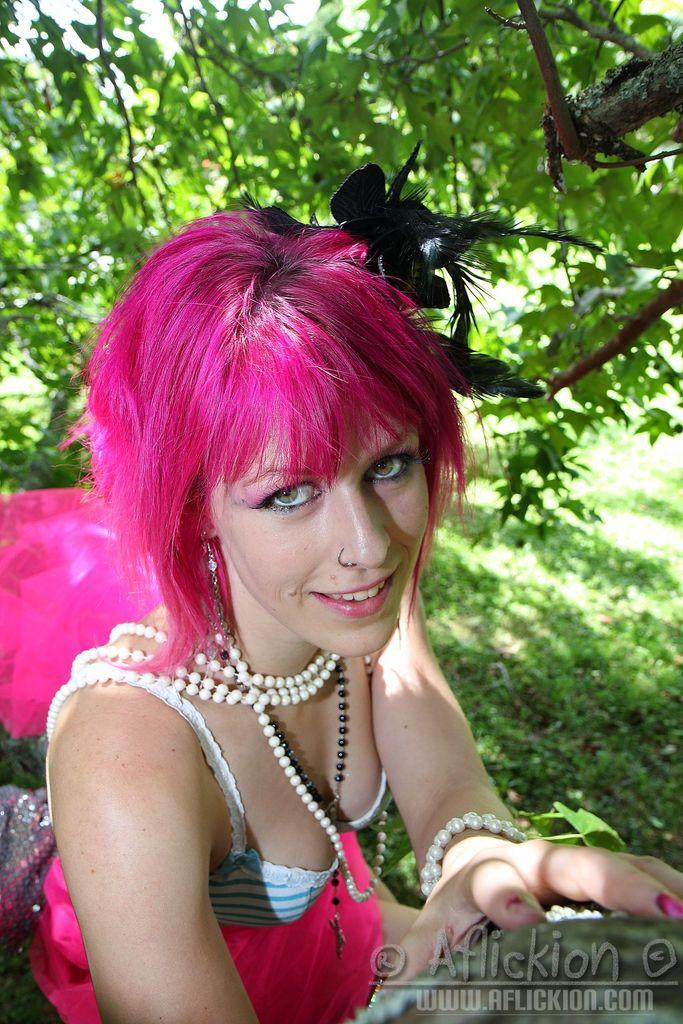Who is present in the image? There is a woman in the image. What is a distinctive feature of the woman's appearance? The woman has pink hair. In which direction is the woman looking? The woman is looking at the side. What type of natural scenery can be seen in the image? There are trees at the top of the image. What can be found at the bottom of the image? There is a watermark at the bottom of the image. What type of marble is visible in the image? There is no marble present in the image. What sound can be heard coming from the sky in the image? There is no sound or thunder present in the image; it is a still image. 